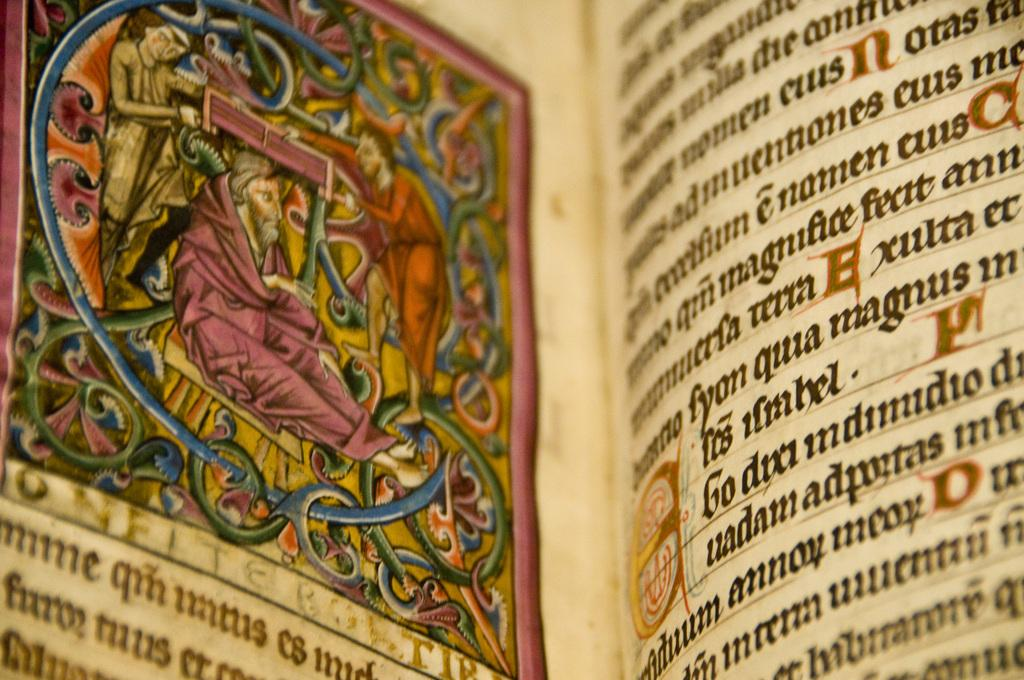Provide a one-sentence caption for the provided image. A book is shown that is written in foreign language and has a colored image in it. 